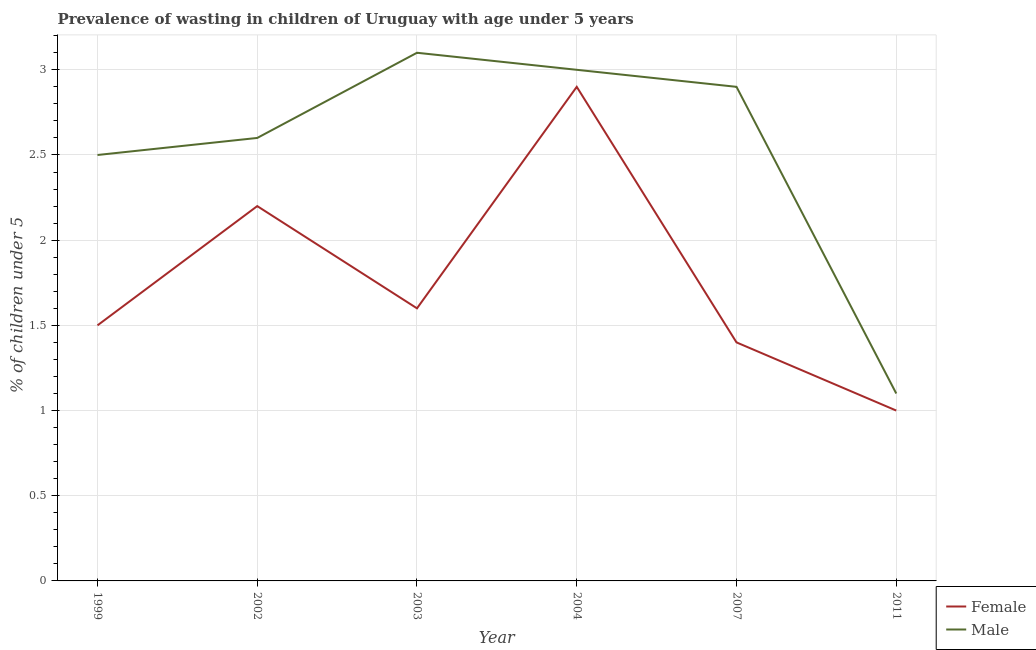Is the number of lines equal to the number of legend labels?
Provide a short and direct response. Yes. What is the percentage of undernourished male children in 2002?
Provide a short and direct response. 2.6. Across all years, what is the maximum percentage of undernourished male children?
Provide a succinct answer. 3.1. Across all years, what is the minimum percentage of undernourished male children?
Offer a very short reply. 1.1. What is the total percentage of undernourished male children in the graph?
Offer a terse response. 15.2. What is the difference between the percentage of undernourished male children in 2002 and that in 2007?
Give a very brief answer. -0.3. What is the average percentage of undernourished female children per year?
Your response must be concise. 1.77. In the year 2003, what is the difference between the percentage of undernourished male children and percentage of undernourished female children?
Ensure brevity in your answer.  1.5. What is the ratio of the percentage of undernourished female children in 2004 to that in 2007?
Give a very brief answer. 2.07. What is the difference between the highest and the second highest percentage of undernourished female children?
Your response must be concise. 0.7. What is the difference between the highest and the lowest percentage of undernourished female children?
Your answer should be compact. 1.9. Is the sum of the percentage of undernourished male children in 2002 and 2004 greater than the maximum percentage of undernourished female children across all years?
Make the answer very short. Yes. Does the percentage of undernourished male children monotonically increase over the years?
Offer a terse response. No. Is the percentage of undernourished male children strictly less than the percentage of undernourished female children over the years?
Offer a terse response. No. How many lines are there?
Your answer should be compact. 2. How many years are there in the graph?
Your answer should be very brief. 6. What is the difference between two consecutive major ticks on the Y-axis?
Your answer should be compact. 0.5. Are the values on the major ticks of Y-axis written in scientific E-notation?
Ensure brevity in your answer.  No. Where does the legend appear in the graph?
Ensure brevity in your answer.  Bottom right. What is the title of the graph?
Your answer should be compact. Prevalence of wasting in children of Uruguay with age under 5 years. What is the label or title of the Y-axis?
Your response must be concise.  % of children under 5. What is the  % of children under 5 in Male in 1999?
Give a very brief answer. 2.5. What is the  % of children under 5 of Female in 2002?
Ensure brevity in your answer.  2.2. What is the  % of children under 5 in Male in 2002?
Provide a succinct answer. 2.6. What is the  % of children under 5 of Female in 2003?
Provide a short and direct response. 1.6. What is the  % of children under 5 in Male in 2003?
Your response must be concise. 3.1. What is the  % of children under 5 in Female in 2004?
Provide a succinct answer. 2.9. What is the  % of children under 5 of Female in 2007?
Your answer should be very brief. 1.4. What is the  % of children under 5 in Male in 2007?
Give a very brief answer. 2.9. What is the  % of children under 5 of Female in 2011?
Ensure brevity in your answer.  1. What is the  % of children under 5 of Male in 2011?
Give a very brief answer. 1.1. Across all years, what is the maximum  % of children under 5 of Female?
Offer a terse response. 2.9. Across all years, what is the maximum  % of children under 5 in Male?
Offer a terse response. 3.1. Across all years, what is the minimum  % of children under 5 in Female?
Offer a very short reply. 1. Across all years, what is the minimum  % of children under 5 in Male?
Keep it short and to the point. 1.1. What is the difference between the  % of children under 5 in Female in 1999 and that in 2002?
Give a very brief answer. -0.7. What is the difference between the  % of children under 5 in Female in 1999 and that in 2004?
Your response must be concise. -1.4. What is the difference between the  % of children under 5 in Male in 1999 and that in 2007?
Ensure brevity in your answer.  -0.4. What is the difference between the  % of children under 5 of Female in 1999 and that in 2011?
Your response must be concise. 0.5. What is the difference between the  % of children under 5 in Male in 1999 and that in 2011?
Your answer should be compact. 1.4. What is the difference between the  % of children under 5 of Female in 2002 and that in 2003?
Provide a short and direct response. 0.6. What is the difference between the  % of children under 5 in Female in 2002 and that in 2004?
Keep it short and to the point. -0.7. What is the difference between the  % of children under 5 of Female in 2002 and that in 2007?
Your answer should be compact. 0.8. What is the difference between the  % of children under 5 in Female in 2002 and that in 2011?
Provide a succinct answer. 1.2. What is the difference between the  % of children under 5 of Male in 2003 and that in 2004?
Your answer should be very brief. 0.1. What is the difference between the  % of children under 5 of Female in 2003 and that in 2007?
Your answer should be very brief. 0.2. What is the difference between the  % of children under 5 of Female in 2003 and that in 2011?
Your answer should be compact. 0.6. What is the difference between the  % of children under 5 in Male in 2004 and that in 2007?
Make the answer very short. 0.1. What is the difference between the  % of children under 5 in Female in 2004 and that in 2011?
Your answer should be compact. 1.9. What is the difference between the  % of children under 5 of Female in 1999 and the  % of children under 5 of Male in 2002?
Offer a very short reply. -1.1. What is the difference between the  % of children under 5 in Female in 1999 and the  % of children under 5 in Male in 2003?
Ensure brevity in your answer.  -1.6. What is the difference between the  % of children under 5 in Female in 1999 and the  % of children under 5 in Male in 2004?
Provide a succinct answer. -1.5. What is the difference between the  % of children under 5 in Female in 2002 and the  % of children under 5 in Male in 2003?
Keep it short and to the point. -0.9. What is the difference between the  % of children under 5 in Female in 2003 and the  % of children under 5 in Male in 2004?
Your answer should be very brief. -1.4. What is the difference between the  % of children under 5 of Female in 2004 and the  % of children under 5 of Male in 2011?
Your response must be concise. 1.8. What is the difference between the  % of children under 5 in Female in 2007 and the  % of children under 5 in Male in 2011?
Your answer should be very brief. 0.3. What is the average  % of children under 5 of Female per year?
Keep it short and to the point. 1.77. What is the average  % of children under 5 in Male per year?
Your answer should be compact. 2.53. What is the ratio of the  % of children under 5 in Female in 1999 to that in 2002?
Keep it short and to the point. 0.68. What is the ratio of the  % of children under 5 of Male in 1999 to that in 2002?
Your response must be concise. 0.96. What is the ratio of the  % of children under 5 of Female in 1999 to that in 2003?
Your answer should be compact. 0.94. What is the ratio of the  % of children under 5 in Male in 1999 to that in 2003?
Ensure brevity in your answer.  0.81. What is the ratio of the  % of children under 5 in Female in 1999 to that in 2004?
Offer a terse response. 0.52. What is the ratio of the  % of children under 5 of Female in 1999 to that in 2007?
Your answer should be very brief. 1.07. What is the ratio of the  % of children under 5 of Male in 1999 to that in 2007?
Provide a short and direct response. 0.86. What is the ratio of the  % of children under 5 in Male in 1999 to that in 2011?
Your response must be concise. 2.27. What is the ratio of the  % of children under 5 of Female in 2002 to that in 2003?
Ensure brevity in your answer.  1.38. What is the ratio of the  % of children under 5 of Male in 2002 to that in 2003?
Your answer should be compact. 0.84. What is the ratio of the  % of children under 5 in Female in 2002 to that in 2004?
Provide a succinct answer. 0.76. What is the ratio of the  % of children under 5 of Male in 2002 to that in 2004?
Provide a short and direct response. 0.87. What is the ratio of the  % of children under 5 of Female in 2002 to that in 2007?
Your answer should be compact. 1.57. What is the ratio of the  % of children under 5 in Male in 2002 to that in 2007?
Keep it short and to the point. 0.9. What is the ratio of the  % of children under 5 in Male in 2002 to that in 2011?
Provide a succinct answer. 2.36. What is the ratio of the  % of children under 5 of Female in 2003 to that in 2004?
Keep it short and to the point. 0.55. What is the ratio of the  % of children under 5 in Male in 2003 to that in 2007?
Provide a short and direct response. 1.07. What is the ratio of the  % of children under 5 in Female in 2003 to that in 2011?
Offer a very short reply. 1.6. What is the ratio of the  % of children under 5 of Male in 2003 to that in 2011?
Your answer should be very brief. 2.82. What is the ratio of the  % of children under 5 in Female in 2004 to that in 2007?
Give a very brief answer. 2.07. What is the ratio of the  % of children under 5 of Male in 2004 to that in 2007?
Give a very brief answer. 1.03. What is the ratio of the  % of children under 5 of Male in 2004 to that in 2011?
Offer a terse response. 2.73. What is the ratio of the  % of children under 5 of Male in 2007 to that in 2011?
Offer a terse response. 2.64. What is the difference between the highest and the second highest  % of children under 5 in Female?
Keep it short and to the point. 0.7. What is the difference between the highest and the second highest  % of children under 5 in Male?
Your answer should be very brief. 0.1. 